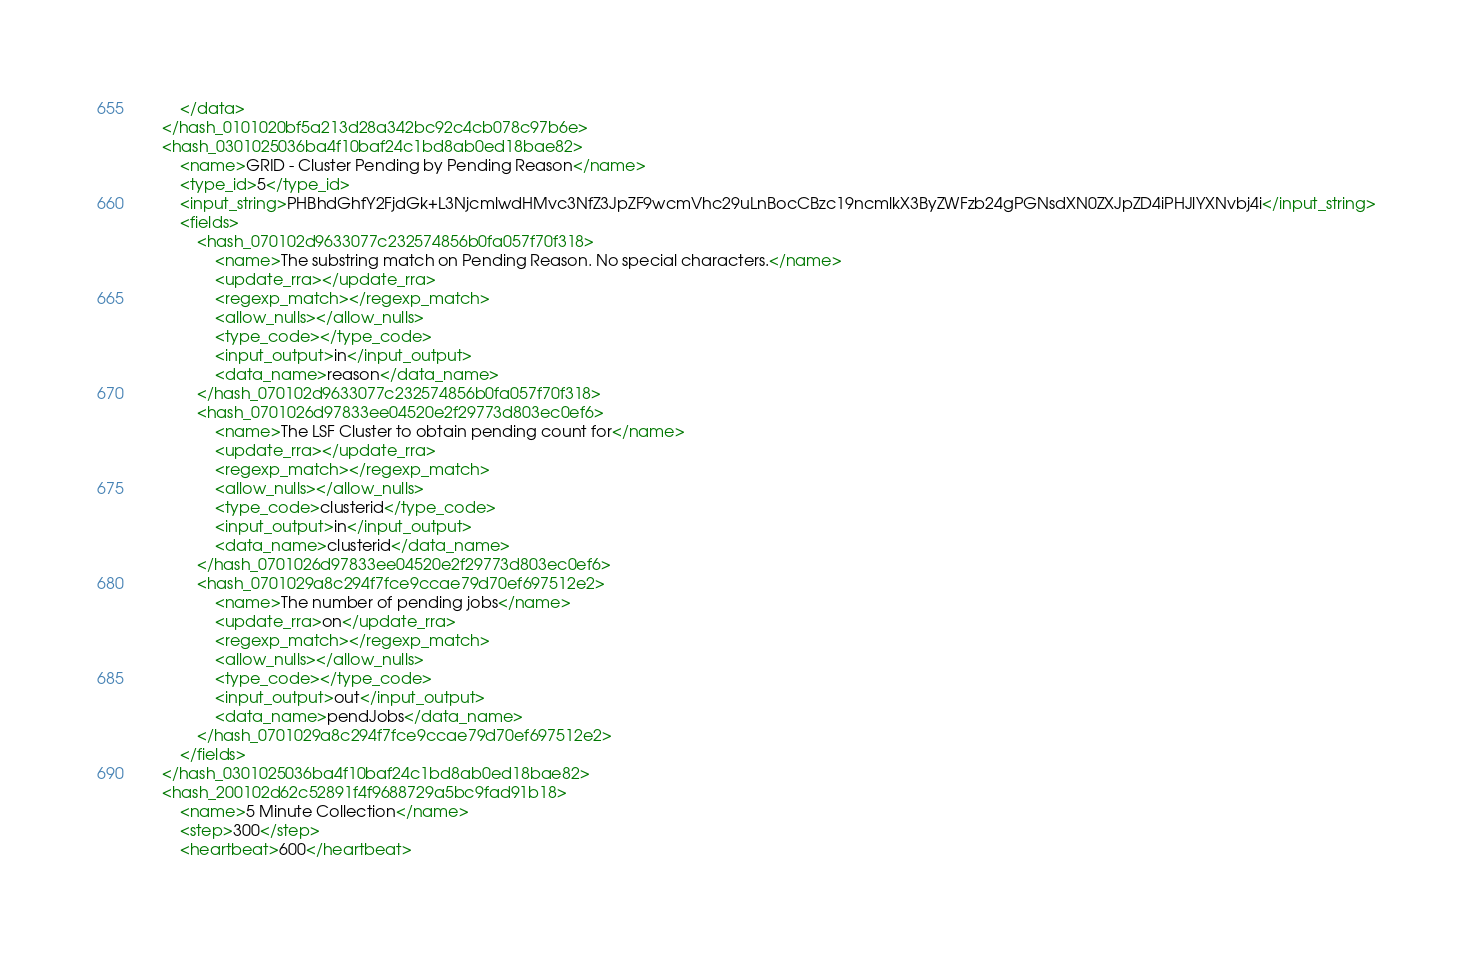Convert code to text. <code><loc_0><loc_0><loc_500><loc_500><_XML_>		</data>
	</hash_0101020bf5a213d28a342bc92c4cb078c97b6e>
	<hash_0301025036ba4f10baf24c1bd8ab0ed18bae82>
		<name>GRID - Cluster Pending by Pending Reason</name>
		<type_id>5</type_id>
		<input_string>PHBhdGhfY2FjdGk+L3NjcmlwdHMvc3NfZ3JpZF9wcmVhc29uLnBocCBzc19ncmlkX3ByZWFzb24gPGNsdXN0ZXJpZD4iPHJlYXNvbj4i</input_string>
		<fields>
			<hash_070102d9633077c232574856b0fa057f70f318>
				<name>The substring match on Pending Reason. No special characters.</name>
				<update_rra></update_rra>
				<regexp_match></regexp_match>
				<allow_nulls></allow_nulls>
				<type_code></type_code>
				<input_output>in</input_output>
				<data_name>reason</data_name>
			</hash_070102d9633077c232574856b0fa057f70f318>
			<hash_0701026d97833ee04520e2f29773d803ec0ef6>
				<name>The LSF Cluster to obtain pending count for</name>
				<update_rra></update_rra>
				<regexp_match></regexp_match>
				<allow_nulls></allow_nulls>
				<type_code>clusterid</type_code>
				<input_output>in</input_output>
				<data_name>clusterid</data_name>
			</hash_0701026d97833ee04520e2f29773d803ec0ef6>
			<hash_0701029a8c294f7fce9ccae79d70ef697512e2>
				<name>The number of pending jobs</name>
				<update_rra>on</update_rra>
				<regexp_match></regexp_match>
				<allow_nulls></allow_nulls>
				<type_code></type_code>
				<input_output>out</input_output>
				<data_name>pendJobs</data_name>
			</hash_0701029a8c294f7fce9ccae79d70ef697512e2>
		</fields>
	</hash_0301025036ba4f10baf24c1bd8ab0ed18bae82>
	<hash_200102d62c52891f4f9688729a5bc9fad91b18>
		<name>5 Minute Collection</name>
		<step>300</step>
		<heartbeat>600</heartbeat></code> 